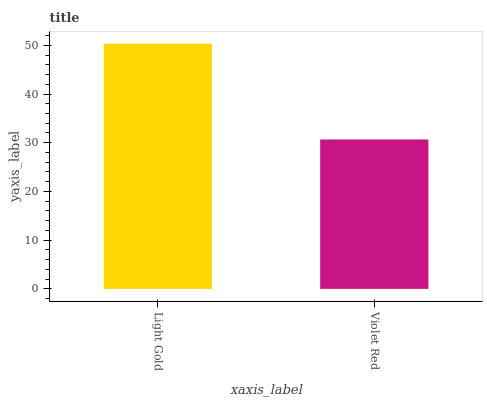Is Violet Red the minimum?
Answer yes or no. Yes. Is Light Gold the maximum?
Answer yes or no. Yes. Is Violet Red the maximum?
Answer yes or no. No. Is Light Gold greater than Violet Red?
Answer yes or no. Yes. Is Violet Red less than Light Gold?
Answer yes or no. Yes. Is Violet Red greater than Light Gold?
Answer yes or no. No. Is Light Gold less than Violet Red?
Answer yes or no. No. Is Light Gold the high median?
Answer yes or no. Yes. Is Violet Red the low median?
Answer yes or no. Yes. Is Violet Red the high median?
Answer yes or no. No. Is Light Gold the low median?
Answer yes or no. No. 